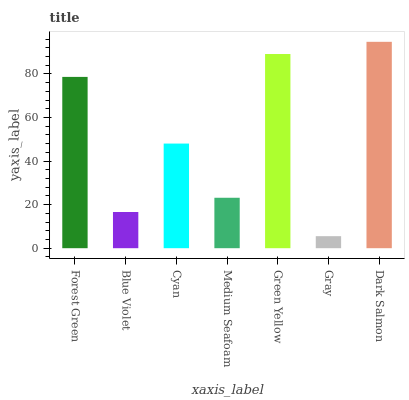Is Gray the minimum?
Answer yes or no. Yes. Is Dark Salmon the maximum?
Answer yes or no. Yes. Is Blue Violet the minimum?
Answer yes or no. No. Is Blue Violet the maximum?
Answer yes or no. No. Is Forest Green greater than Blue Violet?
Answer yes or no. Yes. Is Blue Violet less than Forest Green?
Answer yes or no. Yes. Is Blue Violet greater than Forest Green?
Answer yes or no. No. Is Forest Green less than Blue Violet?
Answer yes or no. No. Is Cyan the high median?
Answer yes or no. Yes. Is Cyan the low median?
Answer yes or no. Yes. Is Dark Salmon the high median?
Answer yes or no. No. Is Medium Seafoam the low median?
Answer yes or no. No. 